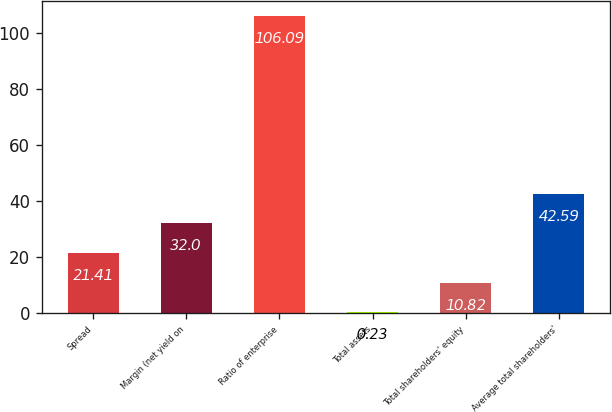<chart> <loc_0><loc_0><loc_500><loc_500><bar_chart><fcel>Spread<fcel>Margin (net yield on<fcel>Ratio of enterprise<fcel>Total assets<fcel>Total shareholders' equity<fcel>Average total shareholders'<nl><fcel>21.41<fcel>32<fcel>106.09<fcel>0.23<fcel>10.82<fcel>42.59<nl></chart> 